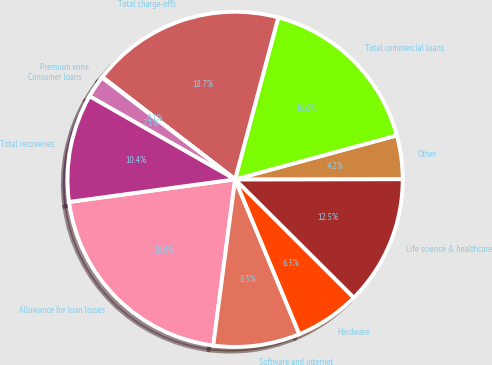Convert chart to OTSL. <chart><loc_0><loc_0><loc_500><loc_500><pie_chart><fcel>Allowance for loan losses<fcel>Software and internet<fcel>Hardware<fcel>Life science & healthcare<fcel>Other<fcel>Total commercial loans<fcel>Total charge-offs<fcel>Premium wine<fcel>Consumer loans<fcel>Total recoveries<nl><fcel>20.77%<fcel>8.34%<fcel>6.27%<fcel>12.49%<fcel>4.2%<fcel>16.63%<fcel>18.7%<fcel>0.06%<fcel>2.13%<fcel>10.41%<nl></chart> 